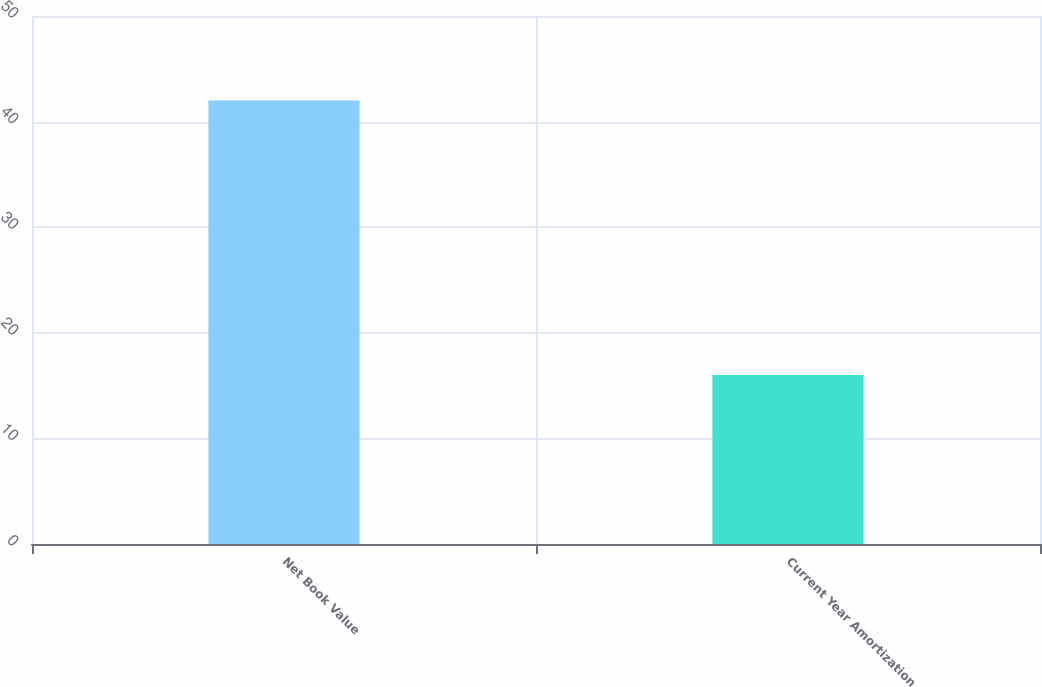Convert chart to OTSL. <chart><loc_0><loc_0><loc_500><loc_500><bar_chart><fcel>Net Book Value<fcel>Current Year Amortization<nl><fcel>42<fcel>16<nl></chart> 